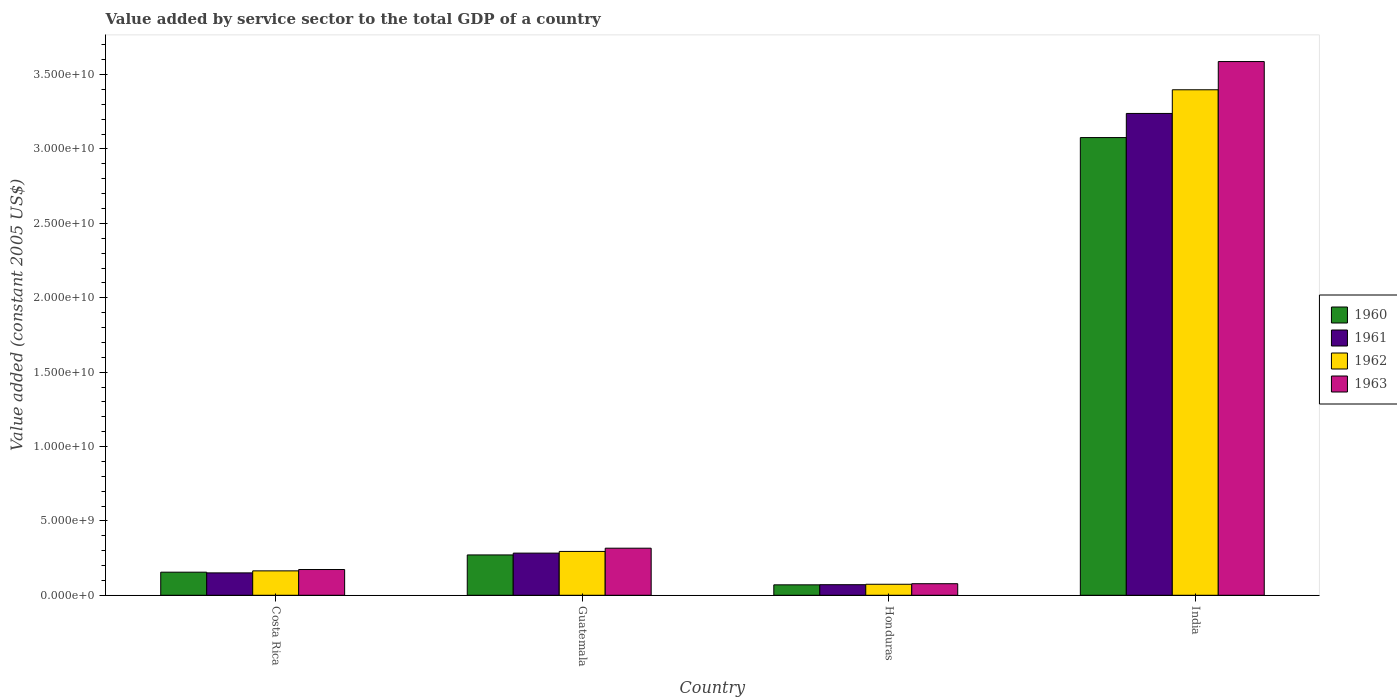Are the number of bars per tick equal to the number of legend labels?
Offer a terse response. Yes. How many bars are there on the 2nd tick from the right?
Offer a very short reply. 4. What is the value added by service sector in 1960 in Honduras?
Offer a very short reply. 7.01e+08. Across all countries, what is the maximum value added by service sector in 1960?
Keep it short and to the point. 3.08e+1. Across all countries, what is the minimum value added by service sector in 1961?
Offer a terse response. 7.12e+08. In which country was the value added by service sector in 1960 maximum?
Ensure brevity in your answer.  India. In which country was the value added by service sector in 1962 minimum?
Ensure brevity in your answer.  Honduras. What is the total value added by service sector in 1960 in the graph?
Ensure brevity in your answer.  3.57e+1. What is the difference between the value added by service sector in 1961 in Costa Rica and that in Honduras?
Your answer should be compact. 7.94e+08. What is the difference between the value added by service sector in 1960 in India and the value added by service sector in 1963 in Guatemala?
Offer a terse response. 2.76e+1. What is the average value added by service sector in 1962 per country?
Offer a terse response. 9.83e+09. What is the difference between the value added by service sector of/in 1962 and value added by service sector of/in 1963 in Guatemala?
Give a very brief answer. -2.17e+08. In how many countries, is the value added by service sector in 1961 greater than 30000000000 US$?
Your answer should be compact. 1. What is the ratio of the value added by service sector in 1961 in Costa Rica to that in India?
Offer a very short reply. 0.05. Is the difference between the value added by service sector in 1962 in Guatemala and Honduras greater than the difference between the value added by service sector in 1963 in Guatemala and Honduras?
Give a very brief answer. No. What is the difference between the highest and the second highest value added by service sector in 1963?
Offer a very short reply. 3.27e+1. What is the difference between the highest and the lowest value added by service sector in 1961?
Ensure brevity in your answer.  3.17e+1. Is the sum of the value added by service sector in 1960 in Guatemala and Honduras greater than the maximum value added by service sector in 1962 across all countries?
Ensure brevity in your answer.  No. Is it the case that in every country, the sum of the value added by service sector in 1962 and value added by service sector in 1963 is greater than the sum of value added by service sector in 1961 and value added by service sector in 1960?
Provide a succinct answer. No. What does the 3rd bar from the left in Costa Rica represents?
Offer a terse response. 1962. What does the 4th bar from the right in Guatemala represents?
Your answer should be very brief. 1960. How many bars are there?
Provide a succinct answer. 16. Does the graph contain any zero values?
Provide a succinct answer. No. How are the legend labels stacked?
Your answer should be very brief. Vertical. What is the title of the graph?
Ensure brevity in your answer.  Value added by service sector to the total GDP of a country. What is the label or title of the X-axis?
Offer a terse response. Country. What is the label or title of the Y-axis?
Ensure brevity in your answer.  Value added (constant 2005 US$). What is the Value added (constant 2005 US$) in 1960 in Costa Rica?
Provide a short and direct response. 1.55e+09. What is the Value added (constant 2005 US$) in 1961 in Costa Rica?
Make the answer very short. 1.51e+09. What is the Value added (constant 2005 US$) in 1962 in Costa Rica?
Offer a very short reply. 1.64e+09. What is the Value added (constant 2005 US$) of 1963 in Costa Rica?
Provide a short and direct response. 1.73e+09. What is the Value added (constant 2005 US$) in 1960 in Guatemala?
Your response must be concise. 2.71e+09. What is the Value added (constant 2005 US$) of 1961 in Guatemala?
Your answer should be compact. 2.83e+09. What is the Value added (constant 2005 US$) in 1962 in Guatemala?
Your answer should be very brief. 2.95e+09. What is the Value added (constant 2005 US$) in 1963 in Guatemala?
Make the answer very short. 3.16e+09. What is the Value added (constant 2005 US$) in 1960 in Honduras?
Keep it short and to the point. 7.01e+08. What is the Value added (constant 2005 US$) of 1961 in Honduras?
Make the answer very short. 7.12e+08. What is the Value added (constant 2005 US$) in 1962 in Honduras?
Keep it short and to the point. 7.41e+08. What is the Value added (constant 2005 US$) of 1963 in Honduras?
Give a very brief answer. 7.78e+08. What is the Value added (constant 2005 US$) of 1960 in India?
Keep it short and to the point. 3.08e+1. What is the Value added (constant 2005 US$) in 1961 in India?
Keep it short and to the point. 3.24e+1. What is the Value added (constant 2005 US$) in 1962 in India?
Keep it short and to the point. 3.40e+1. What is the Value added (constant 2005 US$) in 1963 in India?
Your answer should be compact. 3.59e+1. Across all countries, what is the maximum Value added (constant 2005 US$) in 1960?
Make the answer very short. 3.08e+1. Across all countries, what is the maximum Value added (constant 2005 US$) of 1961?
Your answer should be very brief. 3.24e+1. Across all countries, what is the maximum Value added (constant 2005 US$) of 1962?
Make the answer very short. 3.40e+1. Across all countries, what is the maximum Value added (constant 2005 US$) of 1963?
Your response must be concise. 3.59e+1. Across all countries, what is the minimum Value added (constant 2005 US$) of 1960?
Give a very brief answer. 7.01e+08. Across all countries, what is the minimum Value added (constant 2005 US$) in 1961?
Provide a short and direct response. 7.12e+08. Across all countries, what is the minimum Value added (constant 2005 US$) of 1962?
Give a very brief answer. 7.41e+08. Across all countries, what is the minimum Value added (constant 2005 US$) of 1963?
Give a very brief answer. 7.78e+08. What is the total Value added (constant 2005 US$) in 1960 in the graph?
Offer a terse response. 3.57e+1. What is the total Value added (constant 2005 US$) in 1961 in the graph?
Ensure brevity in your answer.  3.74e+1. What is the total Value added (constant 2005 US$) of 1962 in the graph?
Provide a short and direct response. 3.93e+1. What is the total Value added (constant 2005 US$) of 1963 in the graph?
Your answer should be very brief. 4.16e+1. What is the difference between the Value added (constant 2005 US$) of 1960 in Costa Rica and that in Guatemala?
Provide a short and direct response. -1.16e+09. What is the difference between the Value added (constant 2005 US$) of 1961 in Costa Rica and that in Guatemala?
Provide a short and direct response. -1.33e+09. What is the difference between the Value added (constant 2005 US$) in 1962 in Costa Rica and that in Guatemala?
Keep it short and to the point. -1.31e+09. What is the difference between the Value added (constant 2005 US$) of 1963 in Costa Rica and that in Guatemala?
Make the answer very short. -1.43e+09. What is the difference between the Value added (constant 2005 US$) in 1960 in Costa Rica and that in Honduras?
Your answer should be compact. 8.51e+08. What is the difference between the Value added (constant 2005 US$) of 1961 in Costa Rica and that in Honduras?
Provide a succinct answer. 7.94e+08. What is the difference between the Value added (constant 2005 US$) in 1962 in Costa Rica and that in Honduras?
Give a very brief answer. 9.01e+08. What is the difference between the Value added (constant 2005 US$) of 1963 in Costa Rica and that in Honduras?
Give a very brief answer. 9.53e+08. What is the difference between the Value added (constant 2005 US$) in 1960 in Costa Rica and that in India?
Provide a succinct answer. -2.92e+1. What is the difference between the Value added (constant 2005 US$) in 1961 in Costa Rica and that in India?
Give a very brief answer. -3.09e+1. What is the difference between the Value added (constant 2005 US$) of 1962 in Costa Rica and that in India?
Your response must be concise. -3.23e+1. What is the difference between the Value added (constant 2005 US$) of 1963 in Costa Rica and that in India?
Ensure brevity in your answer.  -3.41e+1. What is the difference between the Value added (constant 2005 US$) in 1960 in Guatemala and that in Honduras?
Ensure brevity in your answer.  2.01e+09. What is the difference between the Value added (constant 2005 US$) in 1961 in Guatemala and that in Honduras?
Your answer should be very brief. 2.12e+09. What is the difference between the Value added (constant 2005 US$) in 1962 in Guatemala and that in Honduras?
Make the answer very short. 2.21e+09. What is the difference between the Value added (constant 2005 US$) of 1963 in Guatemala and that in Honduras?
Provide a succinct answer. 2.39e+09. What is the difference between the Value added (constant 2005 US$) in 1960 in Guatemala and that in India?
Keep it short and to the point. -2.81e+1. What is the difference between the Value added (constant 2005 US$) in 1961 in Guatemala and that in India?
Ensure brevity in your answer.  -2.96e+1. What is the difference between the Value added (constant 2005 US$) in 1962 in Guatemala and that in India?
Your response must be concise. -3.10e+1. What is the difference between the Value added (constant 2005 US$) in 1963 in Guatemala and that in India?
Offer a very short reply. -3.27e+1. What is the difference between the Value added (constant 2005 US$) of 1960 in Honduras and that in India?
Provide a short and direct response. -3.01e+1. What is the difference between the Value added (constant 2005 US$) of 1961 in Honduras and that in India?
Your response must be concise. -3.17e+1. What is the difference between the Value added (constant 2005 US$) in 1962 in Honduras and that in India?
Ensure brevity in your answer.  -3.32e+1. What is the difference between the Value added (constant 2005 US$) in 1963 in Honduras and that in India?
Make the answer very short. -3.51e+1. What is the difference between the Value added (constant 2005 US$) of 1960 in Costa Rica and the Value added (constant 2005 US$) of 1961 in Guatemala?
Offer a terse response. -1.28e+09. What is the difference between the Value added (constant 2005 US$) of 1960 in Costa Rica and the Value added (constant 2005 US$) of 1962 in Guatemala?
Provide a succinct answer. -1.39e+09. What is the difference between the Value added (constant 2005 US$) of 1960 in Costa Rica and the Value added (constant 2005 US$) of 1963 in Guatemala?
Ensure brevity in your answer.  -1.61e+09. What is the difference between the Value added (constant 2005 US$) of 1961 in Costa Rica and the Value added (constant 2005 US$) of 1962 in Guatemala?
Your answer should be compact. -1.44e+09. What is the difference between the Value added (constant 2005 US$) of 1961 in Costa Rica and the Value added (constant 2005 US$) of 1963 in Guatemala?
Your answer should be very brief. -1.66e+09. What is the difference between the Value added (constant 2005 US$) in 1962 in Costa Rica and the Value added (constant 2005 US$) in 1963 in Guatemala?
Your response must be concise. -1.52e+09. What is the difference between the Value added (constant 2005 US$) in 1960 in Costa Rica and the Value added (constant 2005 US$) in 1961 in Honduras?
Keep it short and to the point. 8.41e+08. What is the difference between the Value added (constant 2005 US$) of 1960 in Costa Rica and the Value added (constant 2005 US$) of 1962 in Honduras?
Your response must be concise. 8.12e+08. What is the difference between the Value added (constant 2005 US$) in 1960 in Costa Rica and the Value added (constant 2005 US$) in 1963 in Honduras?
Your answer should be compact. 7.75e+08. What is the difference between the Value added (constant 2005 US$) of 1961 in Costa Rica and the Value added (constant 2005 US$) of 1962 in Honduras?
Make the answer very short. 7.65e+08. What is the difference between the Value added (constant 2005 US$) of 1961 in Costa Rica and the Value added (constant 2005 US$) of 1963 in Honduras?
Provide a short and direct response. 7.28e+08. What is the difference between the Value added (constant 2005 US$) in 1962 in Costa Rica and the Value added (constant 2005 US$) in 1963 in Honduras?
Keep it short and to the point. 8.63e+08. What is the difference between the Value added (constant 2005 US$) of 1960 in Costa Rica and the Value added (constant 2005 US$) of 1961 in India?
Ensure brevity in your answer.  -3.08e+1. What is the difference between the Value added (constant 2005 US$) in 1960 in Costa Rica and the Value added (constant 2005 US$) in 1962 in India?
Your answer should be very brief. -3.24e+1. What is the difference between the Value added (constant 2005 US$) in 1960 in Costa Rica and the Value added (constant 2005 US$) in 1963 in India?
Provide a short and direct response. -3.43e+1. What is the difference between the Value added (constant 2005 US$) of 1961 in Costa Rica and the Value added (constant 2005 US$) of 1962 in India?
Your answer should be compact. -3.25e+1. What is the difference between the Value added (constant 2005 US$) in 1961 in Costa Rica and the Value added (constant 2005 US$) in 1963 in India?
Your answer should be very brief. -3.44e+1. What is the difference between the Value added (constant 2005 US$) in 1962 in Costa Rica and the Value added (constant 2005 US$) in 1963 in India?
Offer a terse response. -3.42e+1. What is the difference between the Value added (constant 2005 US$) of 1960 in Guatemala and the Value added (constant 2005 US$) of 1961 in Honduras?
Give a very brief answer. 2.00e+09. What is the difference between the Value added (constant 2005 US$) in 1960 in Guatemala and the Value added (constant 2005 US$) in 1962 in Honduras?
Keep it short and to the point. 1.97e+09. What is the difference between the Value added (constant 2005 US$) in 1960 in Guatemala and the Value added (constant 2005 US$) in 1963 in Honduras?
Offer a terse response. 1.93e+09. What is the difference between the Value added (constant 2005 US$) of 1961 in Guatemala and the Value added (constant 2005 US$) of 1962 in Honduras?
Offer a very short reply. 2.09e+09. What is the difference between the Value added (constant 2005 US$) in 1961 in Guatemala and the Value added (constant 2005 US$) in 1963 in Honduras?
Ensure brevity in your answer.  2.06e+09. What is the difference between the Value added (constant 2005 US$) in 1962 in Guatemala and the Value added (constant 2005 US$) in 1963 in Honduras?
Your answer should be very brief. 2.17e+09. What is the difference between the Value added (constant 2005 US$) of 1960 in Guatemala and the Value added (constant 2005 US$) of 1961 in India?
Provide a short and direct response. -2.97e+1. What is the difference between the Value added (constant 2005 US$) in 1960 in Guatemala and the Value added (constant 2005 US$) in 1962 in India?
Offer a very short reply. -3.13e+1. What is the difference between the Value added (constant 2005 US$) of 1960 in Guatemala and the Value added (constant 2005 US$) of 1963 in India?
Your response must be concise. -3.32e+1. What is the difference between the Value added (constant 2005 US$) in 1961 in Guatemala and the Value added (constant 2005 US$) in 1962 in India?
Provide a short and direct response. -3.11e+1. What is the difference between the Value added (constant 2005 US$) in 1961 in Guatemala and the Value added (constant 2005 US$) in 1963 in India?
Give a very brief answer. -3.30e+1. What is the difference between the Value added (constant 2005 US$) in 1962 in Guatemala and the Value added (constant 2005 US$) in 1963 in India?
Your answer should be compact. -3.29e+1. What is the difference between the Value added (constant 2005 US$) of 1960 in Honduras and the Value added (constant 2005 US$) of 1961 in India?
Keep it short and to the point. -3.17e+1. What is the difference between the Value added (constant 2005 US$) of 1960 in Honduras and the Value added (constant 2005 US$) of 1962 in India?
Ensure brevity in your answer.  -3.33e+1. What is the difference between the Value added (constant 2005 US$) of 1960 in Honduras and the Value added (constant 2005 US$) of 1963 in India?
Make the answer very short. -3.52e+1. What is the difference between the Value added (constant 2005 US$) in 1961 in Honduras and the Value added (constant 2005 US$) in 1962 in India?
Ensure brevity in your answer.  -3.33e+1. What is the difference between the Value added (constant 2005 US$) in 1961 in Honduras and the Value added (constant 2005 US$) in 1963 in India?
Make the answer very short. -3.52e+1. What is the difference between the Value added (constant 2005 US$) of 1962 in Honduras and the Value added (constant 2005 US$) of 1963 in India?
Your answer should be compact. -3.51e+1. What is the average Value added (constant 2005 US$) in 1960 per country?
Your answer should be compact. 8.93e+09. What is the average Value added (constant 2005 US$) in 1961 per country?
Offer a terse response. 9.36e+09. What is the average Value added (constant 2005 US$) in 1962 per country?
Offer a very short reply. 9.83e+09. What is the average Value added (constant 2005 US$) in 1963 per country?
Offer a terse response. 1.04e+1. What is the difference between the Value added (constant 2005 US$) of 1960 and Value added (constant 2005 US$) of 1961 in Costa Rica?
Provide a short and direct response. 4.72e+07. What is the difference between the Value added (constant 2005 US$) of 1960 and Value added (constant 2005 US$) of 1962 in Costa Rica?
Offer a very short reply. -8.87e+07. What is the difference between the Value added (constant 2005 US$) in 1960 and Value added (constant 2005 US$) in 1963 in Costa Rica?
Give a very brief answer. -1.78e+08. What is the difference between the Value added (constant 2005 US$) in 1961 and Value added (constant 2005 US$) in 1962 in Costa Rica?
Ensure brevity in your answer.  -1.36e+08. What is the difference between the Value added (constant 2005 US$) of 1961 and Value added (constant 2005 US$) of 1963 in Costa Rica?
Provide a succinct answer. -2.25e+08. What is the difference between the Value added (constant 2005 US$) of 1962 and Value added (constant 2005 US$) of 1963 in Costa Rica?
Provide a short and direct response. -8.94e+07. What is the difference between the Value added (constant 2005 US$) of 1960 and Value added (constant 2005 US$) of 1961 in Guatemala?
Ensure brevity in your answer.  -1.22e+08. What is the difference between the Value added (constant 2005 US$) in 1960 and Value added (constant 2005 US$) in 1962 in Guatemala?
Keep it short and to the point. -2.35e+08. What is the difference between the Value added (constant 2005 US$) in 1960 and Value added (constant 2005 US$) in 1963 in Guatemala?
Provide a short and direct response. -4.53e+08. What is the difference between the Value added (constant 2005 US$) of 1961 and Value added (constant 2005 US$) of 1962 in Guatemala?
Provide a short and direct response. -1.14e+08. What is the difference between the Value added (constant 2005 US$) of 1961 and Value added (constant 2005 US$) of 1963 in Guatemala?
Offer a terse response. -3.31e+08. What is the difference between the Value added (constant 2005 US$) in 1962 and Value added (constant 2005 US$) in 1963 in Guatemala?
Your answer should be very brief. -2.17e+08. What is the difference between the Value added (constant 2005 US$) of 1960 and Value added (constant 2005 US$) of 1961 in Honduras?
Keep it short and to the point. -1.04e+07. What is the difference between the Value added (constant 2005 US$) in 1960 and Value added (constant 2005 US$) in 1962 in Honduras?
Make the answer very short. -3.93e+07. What is the difference between the Value added (constant 2005 US$) in 1960 and Value added (constant 2005 US$) in 1963 in Honduras?
Offer a very short reply. -7.65e+07. What is the difference between the Value added (constant 2005 US$) in 1961 and Value added (constant 2005 US$) in 1962 in Honduras?
Keep it short and to the point. -2.89e+07. What is the difference between the Value added (constant 2005 US$) of 1961 and Value added (constant 2005 US$) of 1963 in Honduras?
Your response must be concise. -6.62e+07. What is the difference between the Value added (constant 2005 US$) of 1962 and Value added (constant 2005 US$) of 1963 in Honduras?
Ensure brevity in your answer.  -3.72e+07. What is the difference between the Value added (constant 2005 US$) in 1960 and Value added (constant 2005 US$) in 1961 in India?
Make the answer very short. -1.62e+09. What is the difference between the Value added (constant 2005 US$) of 1960 and Value added (constant 2005 US$) of 1962 in India?
Make the answer very short. -3.21e+09. What is the difference between the Value added (constant 2005 US$) in 1960 and Value added (constant 2005 US$) in 1963 in India?
Your answer should be very brief. -5.11e+09. What is the difference between the Value added (constant 2005 US$) in 1961 and Value added (constant 2005 US$) in 1962 in India?
Provide a short and direct response. -1.59e+09. What is the difference between the Value added (constant 2005 US$) in 1961 and Value added (constant 2005 US$) in 1963 in India?
Keep it short and to the point. -3.49e+09. What is the difference between the Value added (constant 2005 US$) in 1962 and Value added (constant 2005 US$) in 1963 in India?
Offer a terse response. -1.90e+09. What is the ratio of the Value added (constant 2005 US$) of 1960 in Costa Rica to that in Guatemala?
Offer a terse response. 0.57. What is the ratio of the Value added (constant 2005 US$) of 1961 in Costa Rica to that in Guatemala?
Give a very brief answer. 0.53. What is the ratio of the Value added (constant 2005 US$) of 1962 in Costa Rica to that in Guatemala?
Provide a succinct answer. 0.56. What is the ratio of the Value added (constant 2005 US$) of 1963 in Costa Rica to that in Guatemala?
Your answer should be compact. 0.55. What is the ratio of the Value added (constant 2005 US$) in 1960 in Costa Rica to that in Honduras?
Your response must be concise. 2.21. What is the ratio of the Value added (constant 2005 US$) of 1961 in Costa Rica to that in Honduras?
Provide a short and direct response. 2.12. What is the ratio of the Value added (constant 2005 US$) in 1962 in Costa Rica to that in Honduras?
Your answer should be very brief. 2.22. What is the ratio of the Value added (constant 2005 US$) in 1963 in Costa Rica to that in Honduras?
Offer a very short reply. 2.23. What is the ratio of the Value added (constant 2005 US$) of 1960 in Costa Rica to that in India?
Provide a short and direct response. 0.05. What is the ratio of the Value added (constant 2005 US$) of 1961 in Costa Rica to that in India?
Keep it short and to the point. 0.05. What is the ratio of the Value added (constant 2005 US$) of 1962 in Costa Rica to that in India?
Ensure brevity in your answer.  0.05. What is the ratio of the Value added (constant 2005 US$) in 1963 in Costa Rica to that in India?
Give a very brief answer. 0.05. What is the ratio of the Value added (constant 2005 US$) of 1960 in Guatemala to that in Honduras?
Your response must be concise. 3.87. What is the ratio of the Value added (constant 2005 US$) in 1961 in Guatemala to that in Honduras?
Your answer should be very brief. 3.98. What is the ratio of the Value added (constant 2005 US$) of 1962 in Guatemala to that in Honduras?
Your response must be concise. 3.98. What is the ratio of the Value added (constant 2005 US$) of 1963 in Guatemala to that in Honduras?
Ensure brevity in your answer.  4.07. What is the ratio of the Value added (constant 2005 US$) of 1960 in Guatemala to that in India?
Your answer should be very brief. 0.09. What is the ratio of the Value added (constant 2005 US$) in 1961 in Guatemala to that in India?
Your response must be concise. 0.09. What is the ratio of the Value added (constant 2005 US$) in 1962 in Guatemala to that in India?
Make the answer very short. 0.09. What is the ratio of the Value added (constant 2005 US$) in 1963 in Guatemala to that in India?
Your answer should be very brief. 0.09. What is the ratio of the Value added (constant 2005 US$) of 1960 in Honduras to that in India?
Provide a succinct answer. 0.02. What is the ratio of the Value added (constant 2005 US$) in 1961 in Honduras to that in India?
Offer a very short reply. 0.02. What is the ratio of the Value added (constant 2005 US$) of 1962 in Honduras to that in India?
Your response must be concise. 0.02. What is the ratio of the Value added (constant 2005 US$) in 1963 in Honduras to that in India?
Keep it short and to the point. 0.02. What is the difference between the highest and the second highest Value added (constant 2005 US$) in 1960?
Provide a short and direct response. 2.81e+1. What is the difference between the highest and the second highest Value added (constant 2005 US$) of 1961?
Keep it short and to the point. 2.96e+1. What is the difference between the highest and the second highest Value added (constant 2005 US$) of 1962?
Your answer should be very brief. 3.10e+1. What is the difference between the highest and the second highest Value added (constant 2005 US$) in 1963?
Keep it short and to the point. 3.27e+1. What is the difference between the highest and the lowest Value added (constant 2005 US$) of 1960?
Your answer should be very brief. 3.01e+1. What is the difference between the highest and the lowest Value added (constant 2005 US$) of 1961?
Offer a very short reply. 3.17e+1. What is the difference between the highest and the lowest Value added (constant 2005 US$) of 1962?
Your answer should be very brief. 3.32e+1. What is the difference between the highest and the lowest Value added (constant 2005 US$) in 1963?
Ensure brevity in your answer.  3.51e+1. 